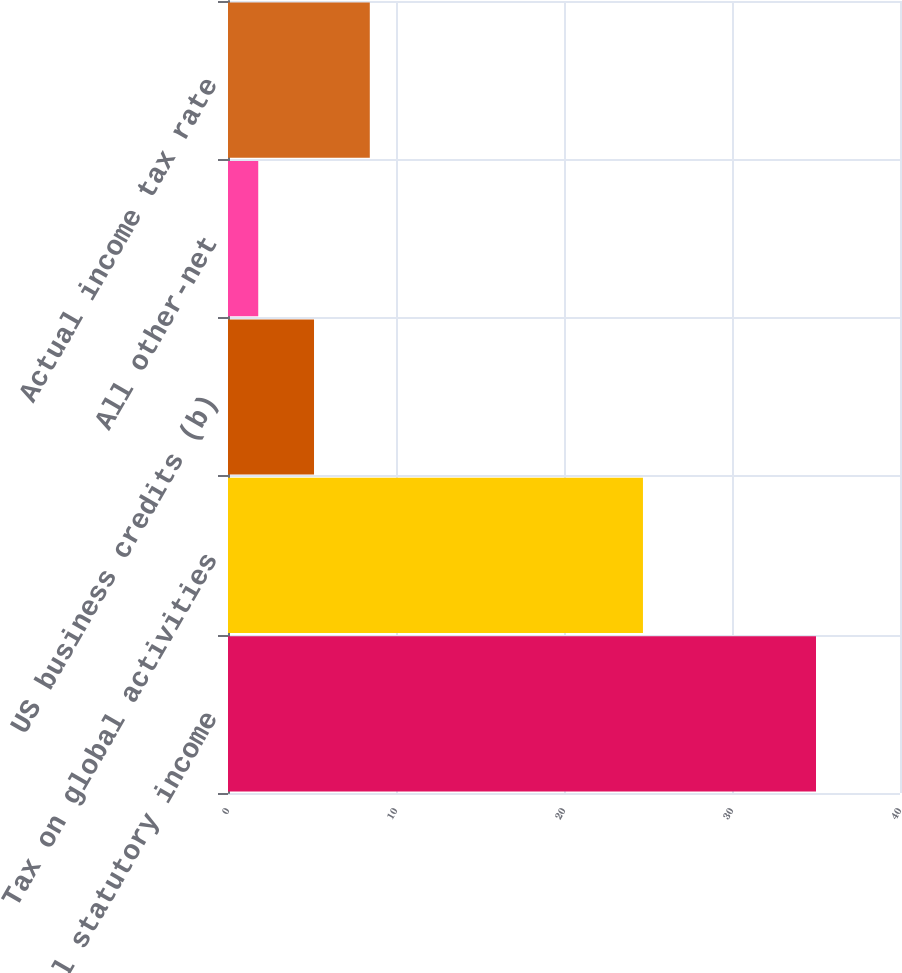Convert chart to OTSL. <chart><loc_0><loc_0><loc_500><loc_500><bar_chart><fcel>US federal statutory income<fcel>Tax on global activities<fcel>US business credits (b)<fcel>All other-net<fcel>Actual income tax rate<nl><fcel>35<fcel>24.7<fcel>5.12<fcel>1.8<fcel>8.44<nl></chart> 